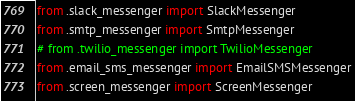<code> <loc_0><loc_0><loc_500><loc_500><_Python_>from .slack_messenger import SlackMessenger
from .smtp_messenger import SmtpMessenger
# from .twilio_messenger import TwilioMessenger
from .email_sms_messenger import EmailSMSMessenger
from .screen_messenger import ScreenMessenger
</code> 